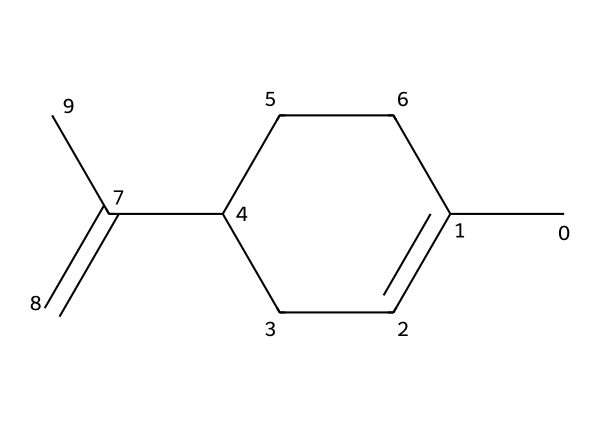What is the molecular formula of limonene? To determine the molecular formula, count the number of carbon (C), hydrogen (H), and other atoms in the structure. The given SMILES representation indicates 10 carbon atoms and 16 hydrogen atoms. Thus, the molecular formula is C10H16.
Answer: C10H16 How many double bonds are present in limonene? The chemical structure can be analyzed for double bonds. In the SMILES representation, we see that there is one double bond (C=C) in the structure. Therefore, limonene contains one double bond.
Answer: 1 What type of terpene is limonene classified as? Limonene is classified as a monoterpene due to having two isoprene units in its structure, which is characteristic of compounds in this classification.
Answer: monoterpene What functional group is characteristic of limonene? The presence of a double bond (C=C) in the structure indicates that limonene is an alkene. This is a key functional group for determining its chemical behavior.
Answer: alkene Does limonene have a cyclic structure? By examining the structure, it is clear that there is a cyclohexane ring in limonene, confirming it has a cyclic part. Specifically, there is a 6-membered carbon ring.
Answer: yes How many hydrogen atoms are attached to the carbon in the ring? By analyzing the structure of the cyclohexane component and the connections, we can see that each carbon in the ring is typically bonded to two hydrogen atoms. Given there are six carbons in the ring, we calculate that 12 hydrogen atoms are bonded to these carbons, while accounting for the hydrogens contributed by the rest of the structure.
Answer: 10 